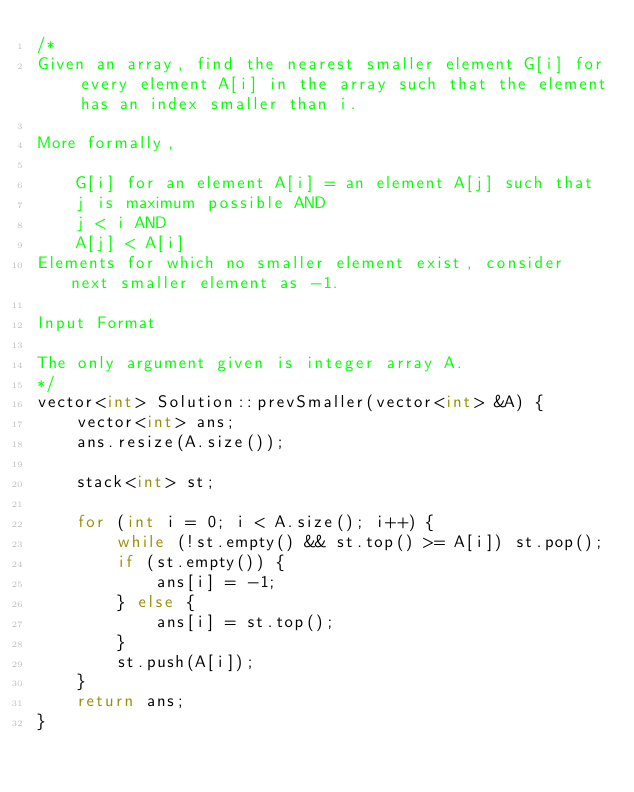<code> <loc_0><loc_0><loc_500><loc_500><_C++_>/*
Given an array, find the nearest smaller element G[i] for every element A[i] in the array such that the element has an index smaller than i.

More formally,

    G[i] for an element A[i] = an element A[j] such that 
    j is maximum possible AND 
    j < i AND
    A[j] < A[i]
Elements for which no smaller element exist, consider next smaller element as -1.

Input Format

The only argument given is integer array A.
*/
vector<int> Solution::prevSmaller(vector<int> &A) {
    vector<int> ans;
    ans.resize(A.size());

    stack<int> st;
    
    for (int i = 0; i < A.size(); i++) {
        while (!st.empty() && st.top() >= A[i]) st.pop();
        if (st.empty()) {
            ans[i] = -1;
        } else {
            ans[i] = st.top();
        }
        st.push(A[i]);
    }
    return ans;
}
</code> 